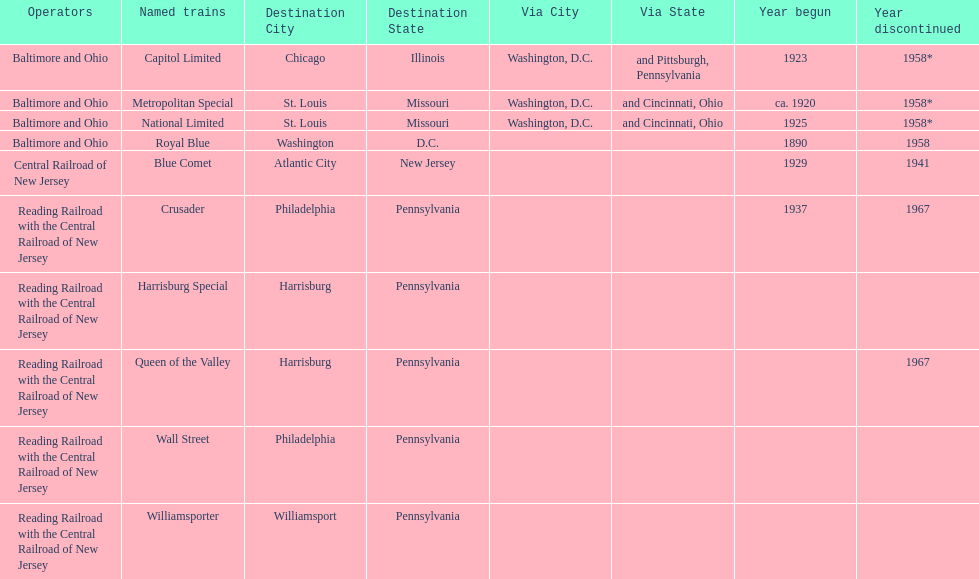What is the difference (in years) between when the royal blue began and the year the crusader began? 47. 